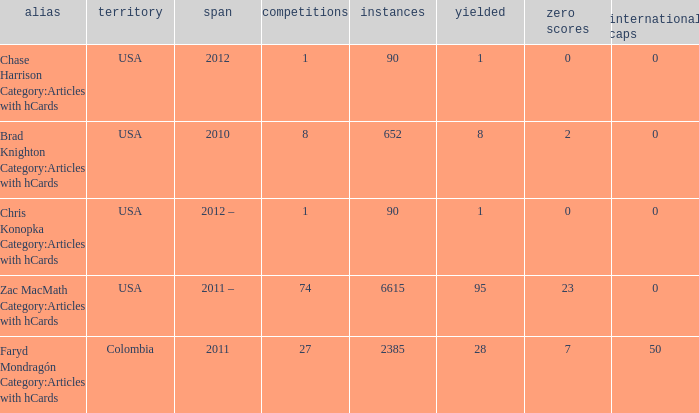When chase harrison category:articles with hcards is the name what is the year? 2012.0. 